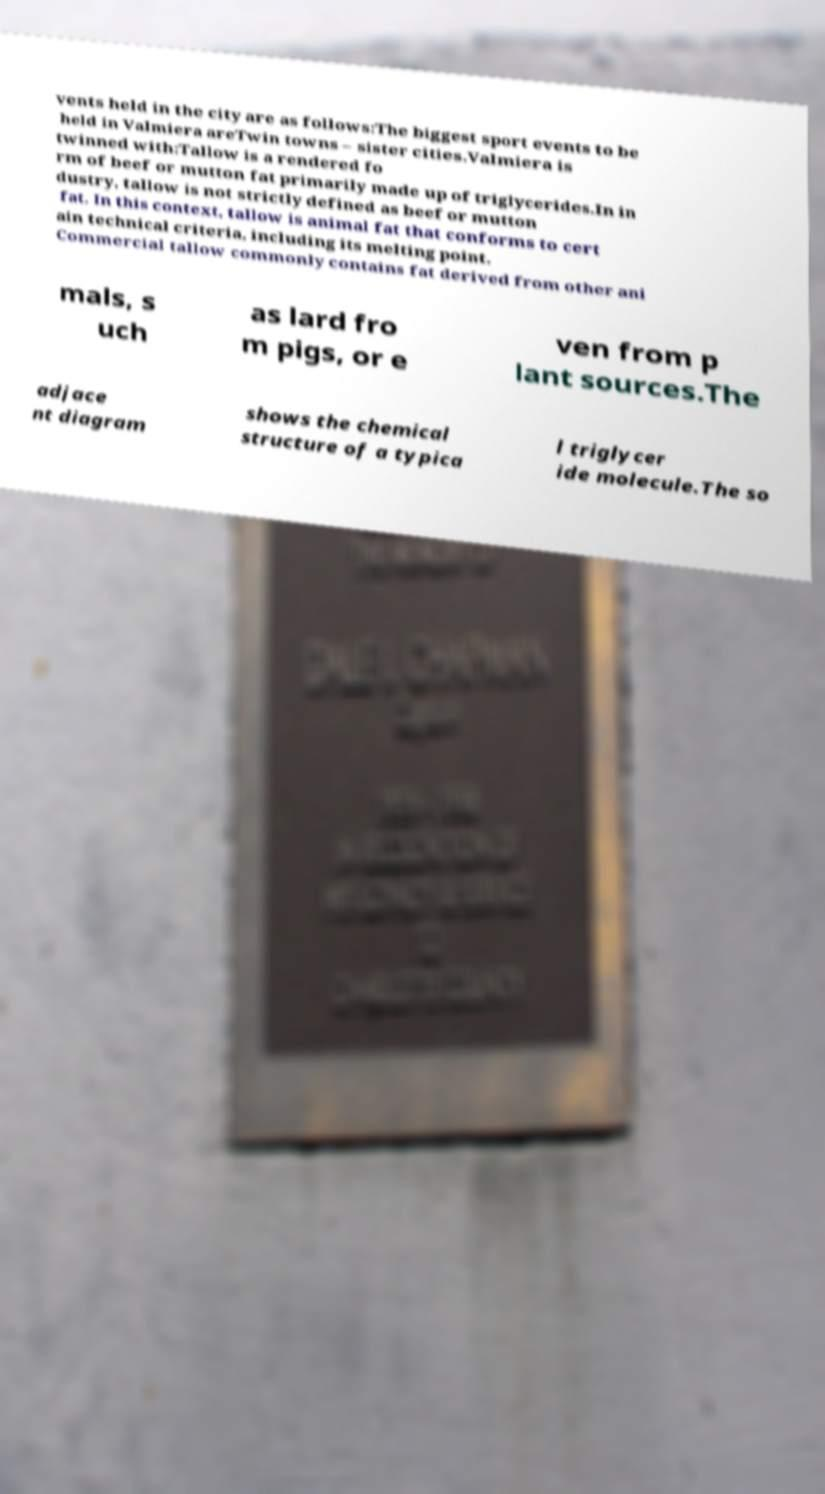Could you extract and type out the text from this image? vents held in the city are as follows:The biggest sport events to be held in Valmiera areTwin towns – sister cities.Valmiera is twinned with:Tallow is a rendered fo rm of beef or mutton fat primarily made up of triglycerides.In in dustry, tallow is not strictly defined as beef or mutton fat. In this context, tallow is animal fat that conforms to cert ain technical criteria, including its melting point. Commercial tallow commonly contains fat derived from other ani mals, s uch as lard fro m pigs, or e ven from p lant sources.The adjace nt diagram shows the chemical structure of a typica l triglycer ide molecule.The so 